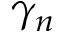<formula> <loc_0><loc_0><loc_500><loc_500>\gamma _ { n }</formula> 